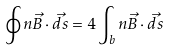<formula> <loc_0><loc_0><loc_500><loc_500>\oint n \vec { B } \cdot \vec { d s } = 4 \int _ { b } n \vec { B } \cdot \vec { d s }</formula> 